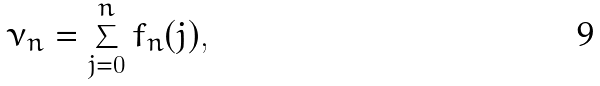Convert formula to latex. <formula><loc_0><loc_0><loc_500><loc_500>\nu _ { n } = \sum _ { j = 0 } ^ { n } f _ { n } ( j ) ,</formula> 